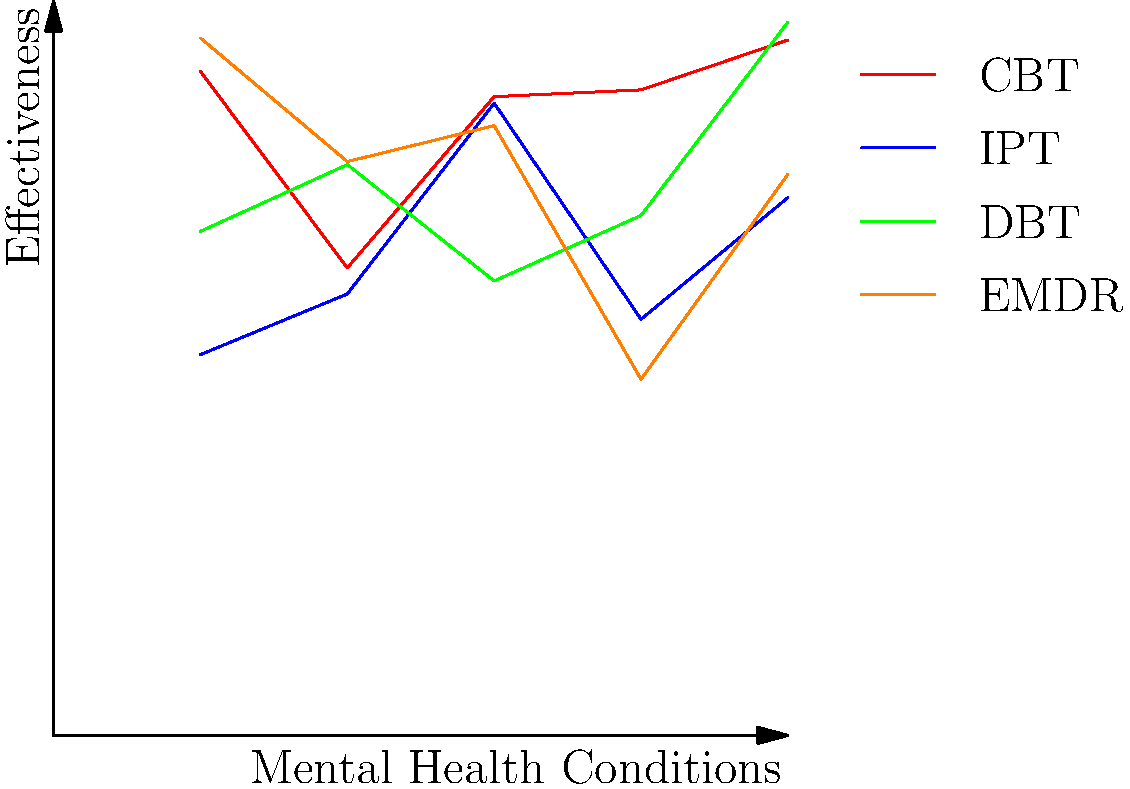Based on the diagram, which therapy approach appears to be most effective across various mental health conditions, and what factors might contribute to its effectiveness? To answer this question, we need to analyze the graph and consider the following steps:

1. Observe the lines representing each therapy approach:
   - CBT (Cognitive Behavioral Therapy): Red line
   - IPT (Interpersonal Therapy): Blue line
   - DBT (Dialectical Behavior Therapy): Green line
   - EMDR (Eye Movement Desensitization and Reprocessing): Orange line

2. Compare the overall height and consistency of each line:
   - CBT appears to have the highest and most consistent line across conditions.
   - Other therapies show more variability in effectiveness.

3. Consider the effectiveness for different conditions:
   - The x-axis represents various mental health conditions.
   - CBT maintains a high level of effectiveness across all conditions.

4. Analyze factors contributing to CBT's effectiveness:
   - Evidence-based: CBT has a strong research foundation.
   - Versatility: It can be adapted to various mental health conditions.
   - Skill-building: Focuses on developing coping strategies.
   - Short-term nature: Often produces results in a relatively short time.
   - Structured approach: Provides clear goals and techniques.

5. Recognize limitations:
   - The graph is a simplified representation and may not reflect all nuances.
   - Individual responses to therapy can vary.

Based on this analysis, CBT appears to be the most effective therapy approach across various mental health conditions according to the diagram.
Answer: Cognitive Behavioral Therapy (CBT) 